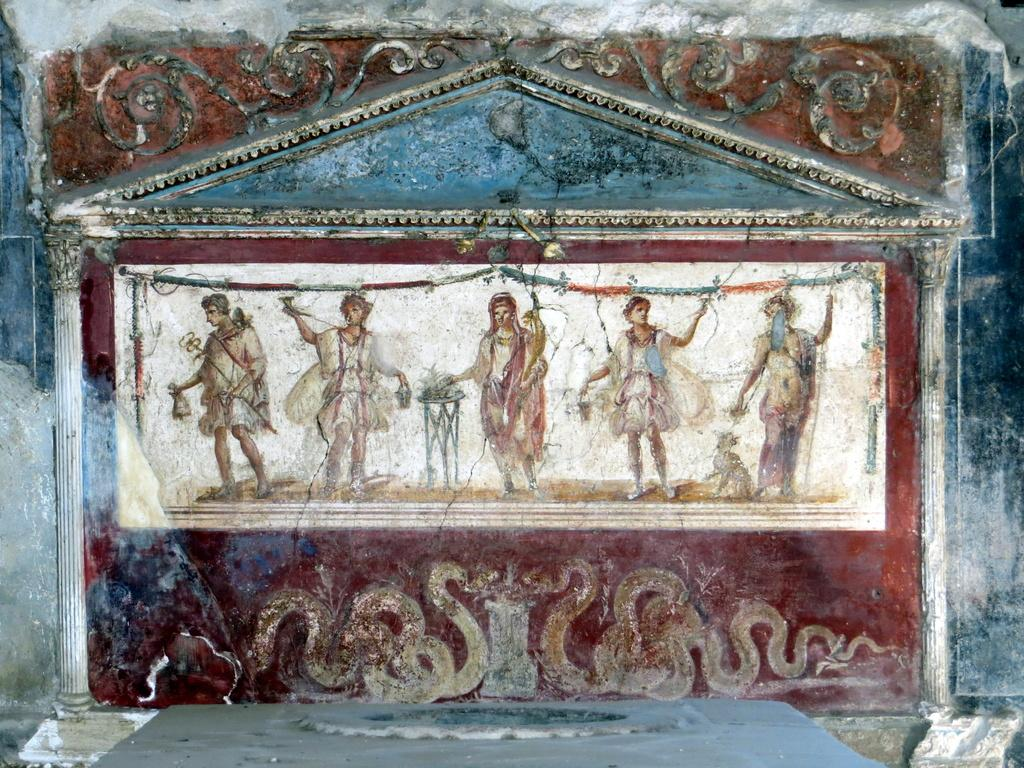What type of structure can be seen in the image? There is a carved wall in the image. How many people are present in the image? There are five people standing in the image. What are the people holding in their hands? The people are holding objects, possibly snakes, in their hands. What architectural features can be seen in the image? There are pillars visible in the image. What type of cactus can be seen growing on the carved wall in the image? There is no cactus visible on the carved wall in the image. 